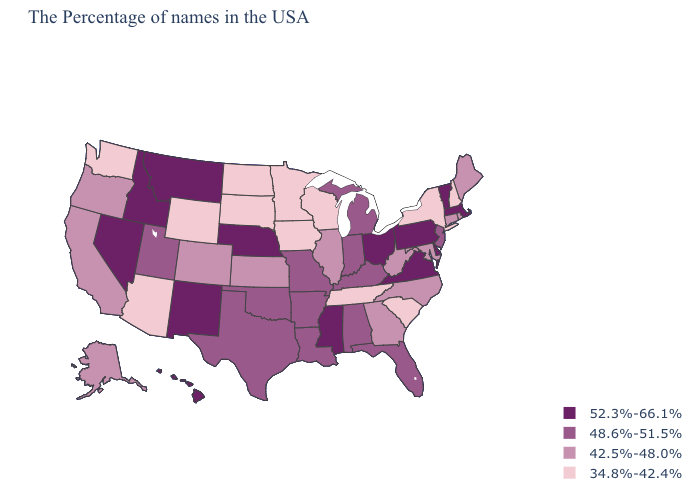Name the states that have a value in the range 52.3%-66.1%?
Give a very brief answer. Massachusetts, Vermont, Delaware, Pennsylvania, Virginia, Ohio, Mississippi, Nebraska, New Mexico, Montana, Idaho, Nevada, Hawaii. Among the states that border Arizona , does Utah have the lowest value?
Keep it brief. No. Does Nebraska have the highest value in the MidWest?
Concise answer only. Yes. What is the highest value in states that border Ohio?
Short answer required. 52.3%-66.1%. What is the value of Kansas?
Give a very brief answer. 42.5%-48.0%. What is the highest value in the USA?
Keep it brief. 52.3%-66.1%. What is the value of Colorado?
Keep it brief. 42.5%-48.0%. Name the states that have a value in the range 48.6%-51.5%?
Give a very brief answer. New Jersey, Florida, Michigan, Kentucky, Indiana, Alabama, Louisiana, Missouri, Arkansas, Oklahoma, Texas, Utah. Name the states that have a value in the range 52.3%-66.1%?
Quick response, please. Massachusetts, Vermont, Delaware, Pennsylvania, Virginia, Ohio, Mississippi, Nebraska, New Mexico, Montana, Idaho, Nevada, Hawaii. Among the states that border New York , which have the lowest value?
Concise answer only. Connecticut. Name the states that have a value in the range 52.3%-66.1%?
Concise answer only. Massachusetts, Vermont, Delaware, Pennsylvania, Virginia, Ohio, Mississippi, Nebraska, New Mexico, Montana, Idaho, Nevada, Hawaii. What is the highest value in states that border Indiana?
Answer briefly. 52.3%-66.1%. What is the highest value in states that border Texas?
Write a very short answer. 52.3%-66.1%. What is the value of Maryland?
Quick response, please. 42.5%-48.0%. What is the value of Arizona?
Concise answer only. 34.8%-42.4%. 